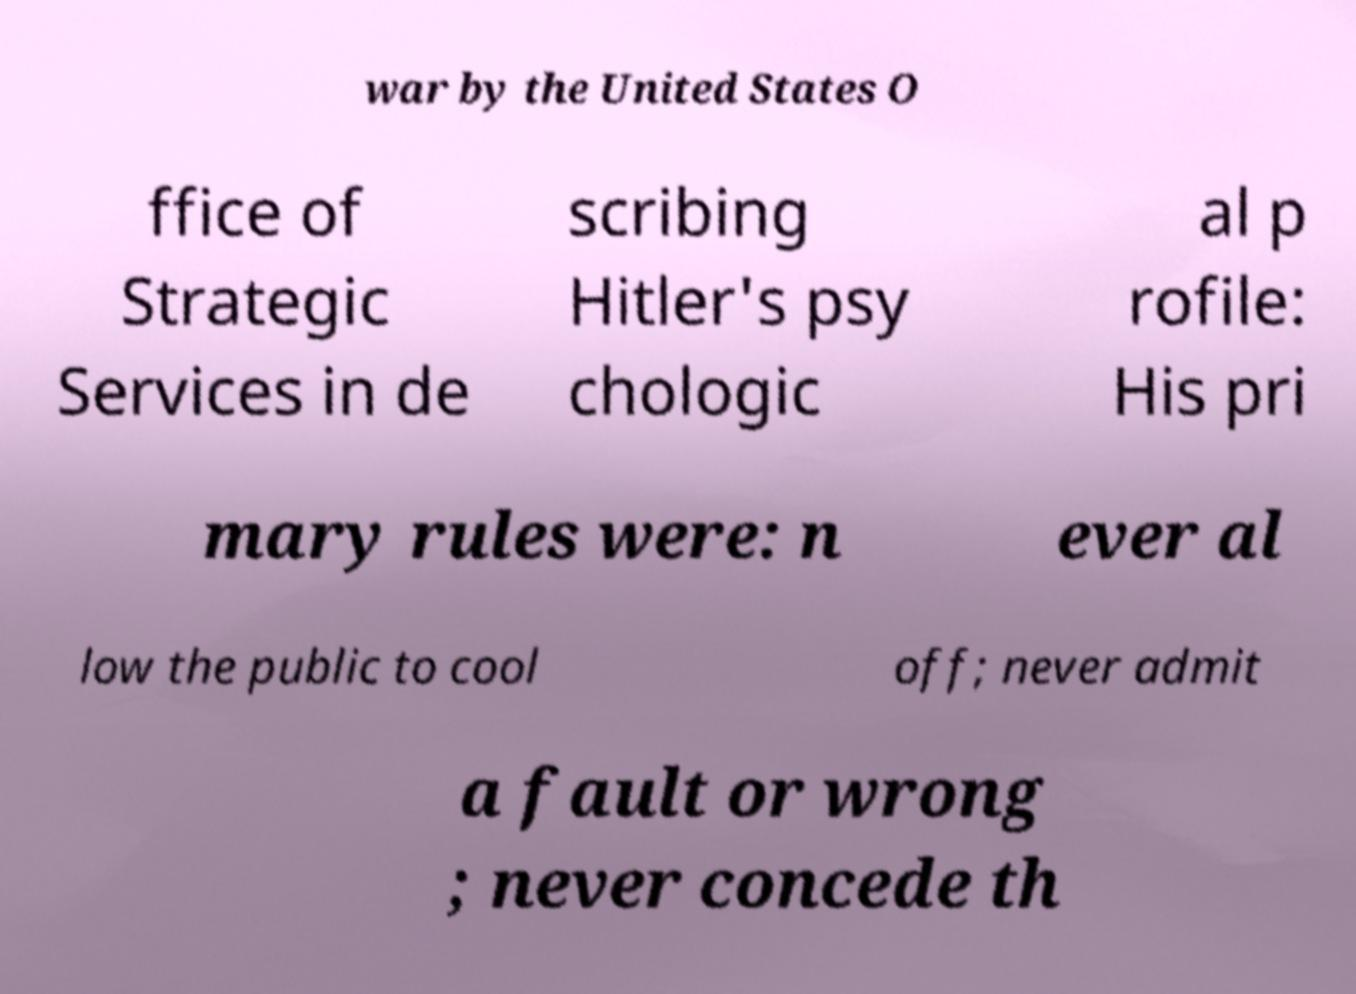I need the written content from this picture converted into text. Can you do that? war by the United States O ffice of Strategic Services in de scribing Hitler's psy chologic al p rofile: His pri mary rules were: n ever al low the public to cool off; never admit a fault or wrong ; never concede th 